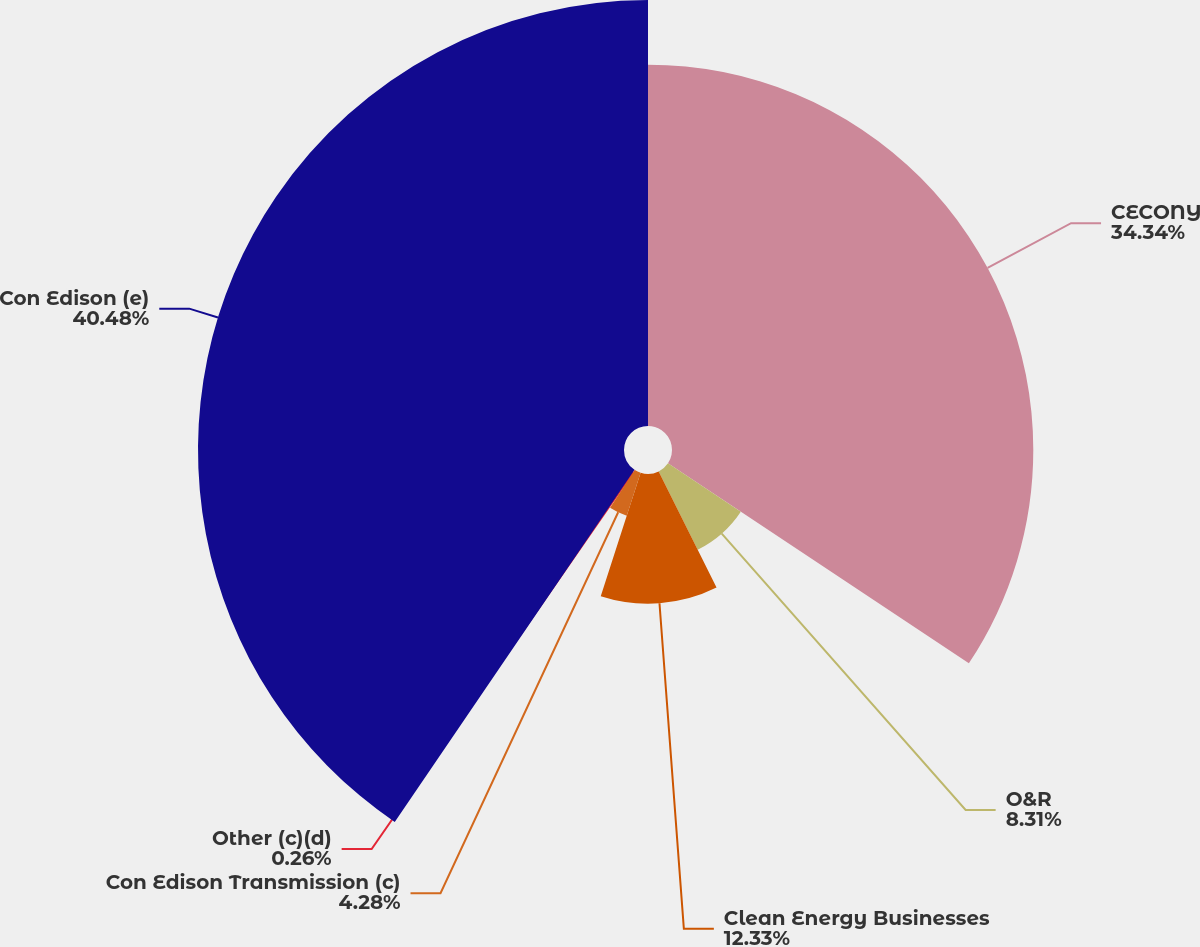Convert chart to OTSL. <chart><loc_0><loc_0><loc_500><loc_500><pie_chart><fcel>CECONY<fcel>O&R<fcel>Clean Energy Businesses<fcel>Con Edison Transmission (c)<fcel>Other (c)(d)<fcel>Con Edison (e)<nl><fcel>34.34%<fcel>8.31%<fcel>12.33%<fcel>4.28%<fcel>0.26%<fcel>40.49%<nl></chart> 